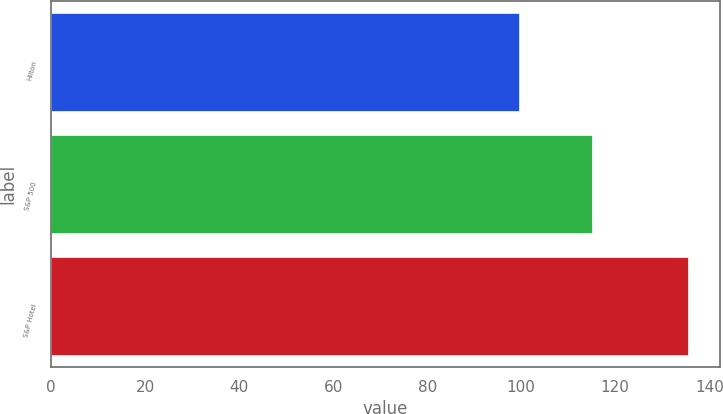Convert chart. <chart><loc_0><loc_0><loc_500><loc_500><bar_chart><fcel>Hilton<fcel>S&P 500<fcel>S&P Hotel<nl><fcel>99.53<fcel>115.12<fcel>135.47<nl></chart> 